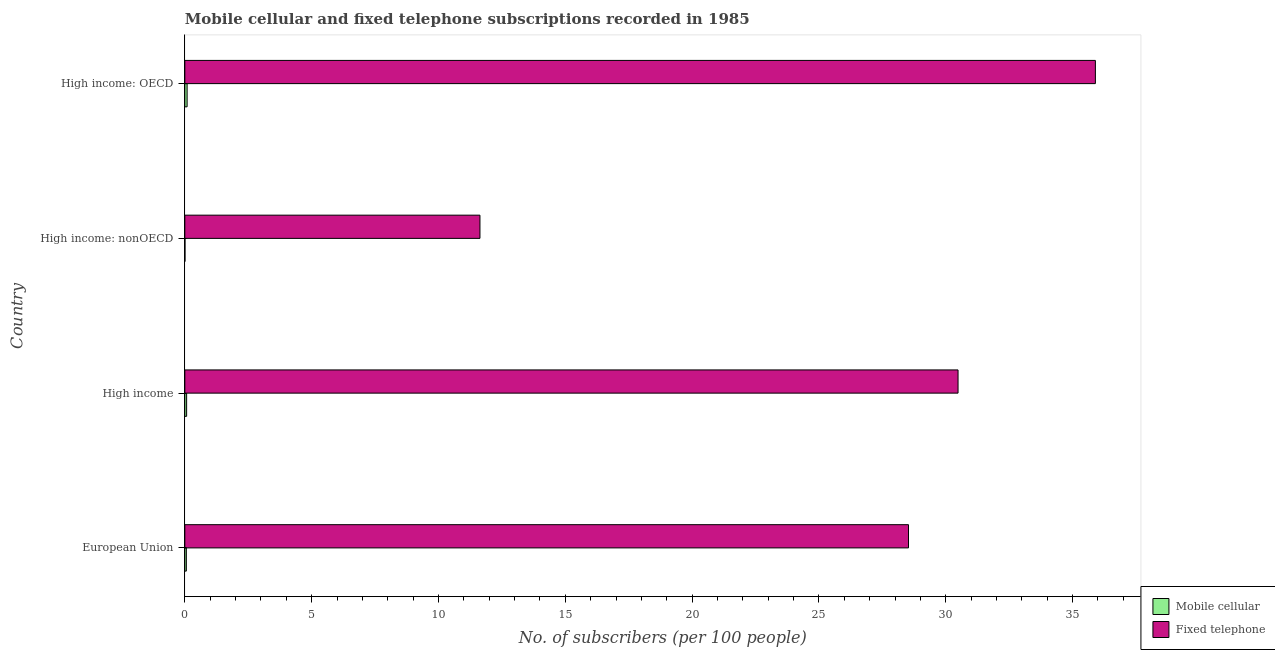How many different coloured bars are there?
Offer a terse response. 2. Are the number of bars per tick equal to the number of legend labels?
Offer a very short reply. Yes. What is the number of fixed telephone subscribers in High income: OECD?
Make the answer very short. 35.9. Across all countries, what is the maximum number of mobile cellular subscribers?
Your response must be concise. 0.09. Across all countries, what is the minimum number of mobile cellular subscribers?
Provide a succinct answer. 0.01. In which country was the number of mobile cellular subscribers maximum?
Your response must be concise. High income: OECD. In which country was the number of fixed telephone subscribers minimum?
Your answer should be very brief. High income: nonOECD. What is the total number of mobile cellular subscribers in the graph?
Offer a terse response. 0.23. What is the difference between the number of mobile cellular subscribers in High income and that in High income: OECD?
Your response must be concise. -0.02. What is the difference between the number of mobile cellular subscribers in High income: nonOECD and the number of fixed telephone subscribers in European Union?
Your answer should be compact. -28.53. What is the average number of mobile cellular subscribers per country?
Offer a terse response. 0.06. What is the difference between the number of fixed telephone subscribers and number of mobile cellular subscribers in High income: OECD?
Ensure brevity in your answer.  35.81. In how many countries, is the number of fixed telephone subscribers greater than 15 ?
Provide a short and direct response. 3. What is the ratio of the number of mobile cellular subscribers in European Union to that in High income: OECD?
Ensure brevity in your answer.  0.67. Is the difference between the number of fixed telephone subscribers in High income and High income: nonOECD greater than the difference between the number of mobile cellular subscribers in High income and High income: nonOECD?
Provide a short and direct response. Yes. What is the difference between the highest and the second highest number of fixed telephone subscribers?
Offer a very short reply. 5.42. What is the difference between the highest and the lowest number of fixed telephone subscribers?
Your response must be concise. 24.26. Is the sum of the number of fixed telephone subscribers in European Union and High income greater than the maximum number of mobile cellular subscribers across all countries?
Provide a succinct answer. Yes. What does the 2nd bar from the top in European Union represents?
Your answer should be very brief. Mobile cellular. What does the 2nd bar from the bottom in High income represents?
Provide a short and direct response. Fixed telephone. How many bars are there?
Your response must be concise. 8. What is the difference between two consecutive major ticks on the X-axis?
Your response must be concise. 5. Are the values on the major ticks of X-axis written in scientific E-notation?
Provide a short and direct response. No. Does the graph contain any zero values?
Your answer should be compact. No. Where does the legend appear in the graph?
Your answer should be very brief. Bottom right. How many legend labels are there?
Make the answer very short. 2. What is the title of the graph?
Your response must be concise. Mobile cellular and fixed telephone subscriptions recorded in 1985. What is the label or title of the X-axis?
Give a very brief answer. No. of subscribers (per 100 people). What is the No. of subscribers (per 100 people) in Mobile cellular in European Union?
Ensure brevity in your answer.  0.06. What is the No. of subscribers (per 100 people) in Fixed telephone in European Union?
Your answer should be very brief. 28.53. What is the No. of subscribers (per 100 people) in Mobile cellular in High income?
Offer a terse response. 0.07. What is the No. of subscribers (per 100 people) in Fixed telephone in High income?
Provide a short and direct response. 30.48. What is the No. of subscribers (per 100 people) in Mobile cellular in High income: nonOECD?
Provide a short and direct response. 0.01. What is the No. of subscribers (per 100 people) in Fixed telephone in High income: nonOECD?
Offer a very short reply. 11.64. What is the No. of subscribers (per 100 people) of Mobile cellular in High income: OECD?
Your answer should be very brief. 0.09. What is the No. of subscribers (per 100 people) in Fixed telephone in High income: OECD?
Your answer should be very brief. 35.9. Across all countries, what is the maximum No. of subscribers (per 100 people) of Mobile cellular?
Offer a terse response. 0.09. Across all countries, what is the maximum No. of subscribers (per 100 people) in Fixed telephone?
Offer a very short reply. 35.9. Across all countries, what is the minimum No. of subscribers (per 100 people) in Mobile cellular?
Ensure brevity in your answer.  0.01. Across all countries, what is the minimum No. of subscribers (per 100 people) of Fixed telephone?
Make the answer very short. 11.64. What is the total No. of subscribers (per 100 people) of Mobile cellular in the graph?
Provide a short and direct response. 0.23. What is the total No. of subscribers (per 100 people) in Fixed telephone in the graph?
Provide a succinct answer. 106.55. What is the difference between the No. of subscribers (per 100 people) in Mobile cellular in European Union and that in High income?
Provide a succinct answer. -0.01. What is the difference between the No. of subscribers (per 100 people) in Fixed telephone in European Union and that in High income?
Your response must be concise. -1.95. What is the difference between the No. of subscribers (per 100 people) of Mobile cellular in European Union and that in High income: nonOECD?
Your answer should be compact. 0.05. What is the difference between the No. of subscribers (per 100 people) of Fixed telephone in European Union and that in High income: nonOECD?
Provide a short and direct response. 16.89. What is the difference between the No. of subscribers (per 100 people) in Mobile cellular in European Union and that in High income: OECD?
Provide a succinct answer. -0.03. What is the difference between the No. of subscribers (per 100 people) in Fixed telephone in European Union and that in High income: OECD?
Ensure brevity in your answer.  -7.37. What is the difference between the No. of subscribers (per 100 people) in Mobile cellular in High income and that in High income: nonOECD?
Make the answer very short. 0.07. What is the difference between the No. of subscribers (per 100 people) of Fixed telephone in High income and that in High income: nonOECD?
Your response must be concise. 18.85. What is the difference between the No. of subscribers (per 100 people) of Mobile cellular in High income and that in High income: OECD?
Keep it short and to the point. -0.02. What is the difference between the No. of subscribers (per 100 people) of Fixed telephone in High income and that in High income: OECD?
Offer a terse response. -5.41. What is the difference between the No. of subscribers (per 100 people) in Mobile cellular in High income: nonOECD and that in High income: OECD?
Ensure brevity in your answer.  -0.08. What is the difference between the No. of subscribers (per 100 people) of Fixed telephone in High income: nonOECD and that in High income: OECD?
Your answer should be very brief. -24.26. What is the difference between the No. of subscribers (per 100 people) in Mobile cellular in European Union and the No. of subscribers (per 100 people) in Fixed telephone in High income?
Your answer should be very brief. -30.42. What is the difference between the No. of subscribers (per 100 people) of Mobile cellular in European Union and the No. of subscribers (per 100 people) of Fixed telephone in High income: nonOECD?
Your answer should be very brief. -11.58. What is the difference between the No. of subscribers (per 100 people) of Mobile cellular in European Union and the No. of subscribers (per 100 people) of Fixed telephone in High income: OECD?
Your response must be concise. -35.84. What is the difference between the No. of subscribers (per 100 people) of Mobile cellular in High income and the No. of subscribers (per 100 people) of Fixed telephone in High income: nonOECD?
Give a very brief answer. -11.56. What is the difference between the No. of subscribers (per 100 people) in Mobile cellular in High income and the No. of subscribers (per 100 people) in Fixed telephone in High income: OECD?
Your answer should be very brief. -35.83. What is the difference between the No. of subscribers (per 100 people) in Mobile cellular in High income: nonOECD and the No. of subscribers (per 100 people) in Fixed telephone in High income: OECD?
Your answer should be very brief. -35.89. What is the average No. of subscribers (per 100 people) of Mobile cellular per country?
Provide a short and direct response. 0.06. What is the average No. of subscribers (per 100 people) in Fixed telephone per country?
Offer a terse response. 26.64. What is the difference between the No. of subscribers (per 100 people) in Mobile cellular and No. of subscribers (per 100 people) in Fixed telephone in European Union?
Offer a terse response. -28.47. What is the difference between the No. of subscribers (per 100 people) of Mobile cellular and No. of subscribers (per 100 people) of Fixed telephone in High income?
Provide a succinct answer. -30.41. What is the difference between the No. of subscribers (per 100 people) in Mobile cellular and No. of subscribers (per 100 people) in Fixed telephone in High income: nonOECD?
Make the answer very short. -11.63. What is the difference between the No. of subscribers (per 100 people) of Mobile cellular and No. of subscribers (per 100 people) of Fixed telephone in High income: OECD?
Keep it short and to the point. -35.81. What is the ratio of the No. of subscribers (per 100 people) of Mobile cellular in European Union to that in High income?
Your answer should be very brief. 0.85. What is the ratio of the No. of subscribers (per 100 people) in Fixed telephone in European Union to that in High income?
Give a very brief answer. 0.94. What is the ratio of the No. of subscribers (per 100 people) in Mobile cellular in European Union to that in High income: nonOECD?
Make the answer very short. 11.75. What is the ratio of the No. of subscribers (per 100 people) of Fixed telephone in European Union to that in High income: nonOECD?
Provide a succinct answer. 2.45. What is the ratio of the No. of subscribers (per 100 people) in Mobile cellular in European Union to that in High income: OECD?
Offer a terse response. 0.67. What is the ratio of the No. of subscribers (per 100 people) of Fixed telephone in European Union to that in High income: OECD?
Provide a succinct answer. 0.79. What is the ratio of the No. of subscribers (per 100 people) in Mobile cellular in High income to that in High income: nonOECD?
Offer a very short reply. 13.83. What is the ratio of the No. of subscribers (per 100 people) of Fixed telephone in High income to that in High income: nonOECD?
Offer a very short reply. 2.62. What is the ratio of the No. of subscribers (per 100 people) of Mobile cellular in High income to that in High income: OECD?
Your answer should be compact. 0.78. What is the ratio of the No. of subscribers (per 100 people) in Fixed telephone in High income to that in High income: OECD?
Your answer should be very brief. 0.85. What is the ratio of the No. of subscribers (per 100 people) in Mobile cellular in High income: nonOECD to that in High income: OECD?
Offer a very short reply. 0.06. What is the ratio of the No. of subscribers (per 100 people) of Fixed telephone in High income: nonOECD to that in High income: OECD?
Offer a very short reply. 0.32. What is the difference between the highest and the second highest No. of subscribers (per 100 people) in Mobile cellular?
Offer a very short reply. 0.02. What is the difference between the highest and the second highest No. of subscribers (per 100 people) of Fixed telephone?
Offer a very short reply. 5.41. What is the difference between the highest and the lowest No. of subscribers (per 100 people) of Mobile cellular?
Provide a succinct answer. 0.08. What is the difference between the highest and the lowest No. of subscribers (per 100 people) of Fixed telephone?
Offer a terse response. 24.26. 